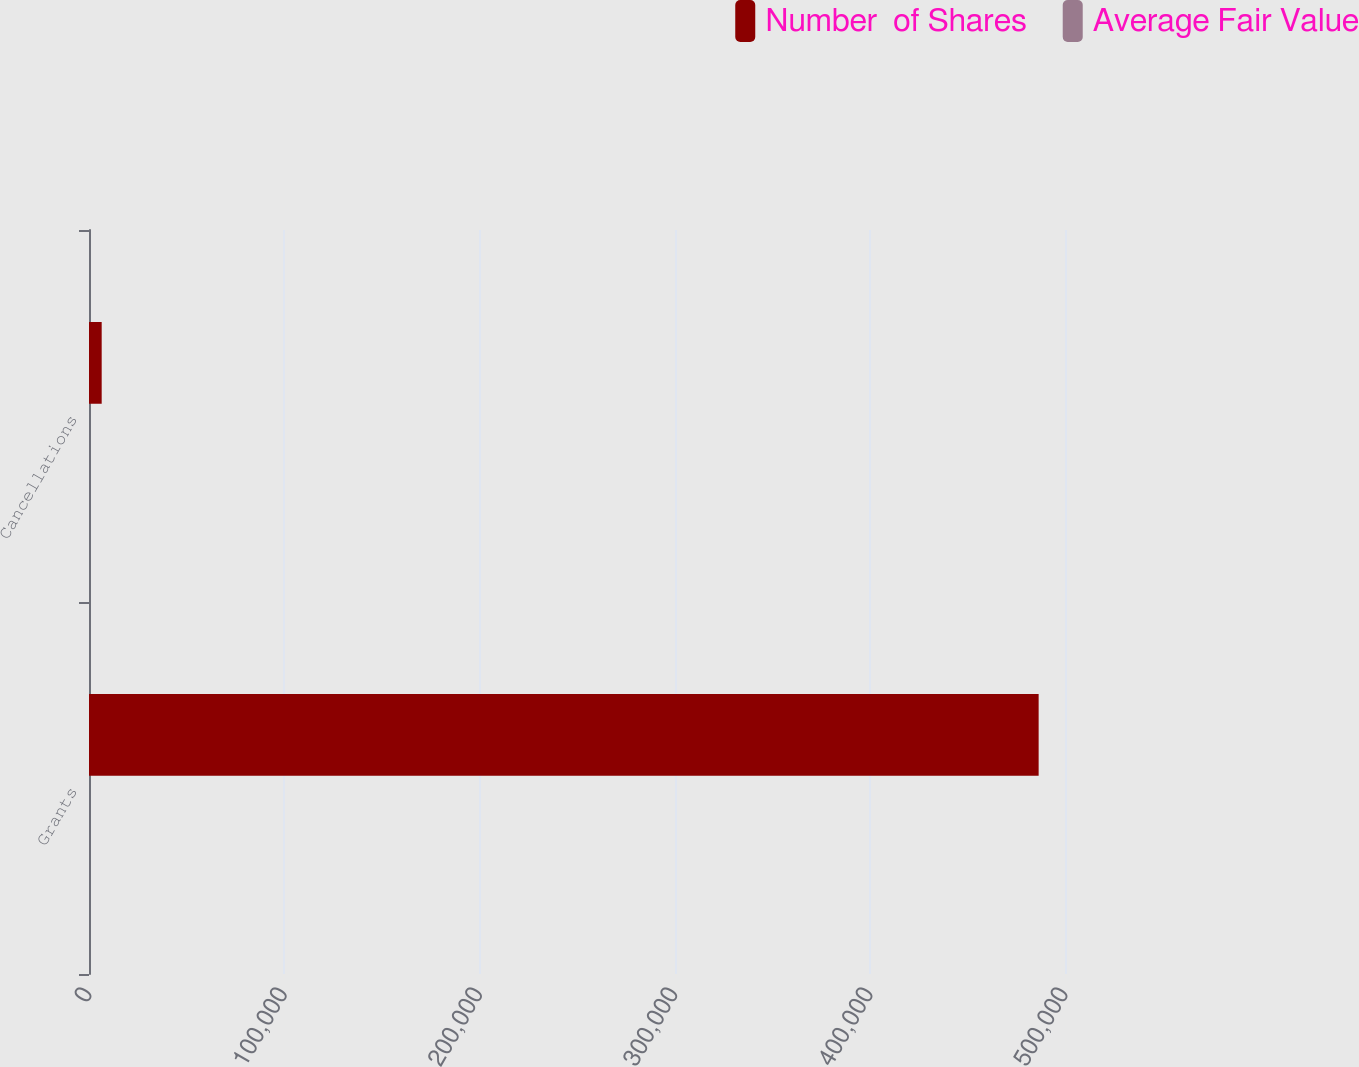<chart> <loc_0><loc_0><loc_500><loc_500><stacked_bar_chart><ecel><fcel>Grants<fcel>Cancellations<nl><fcel>Number  of Shares<fcel>486500<fcel>6500<nl><fcel>Average Fair Value<fcel>25.86<fcel>25.6<nl></chart> 